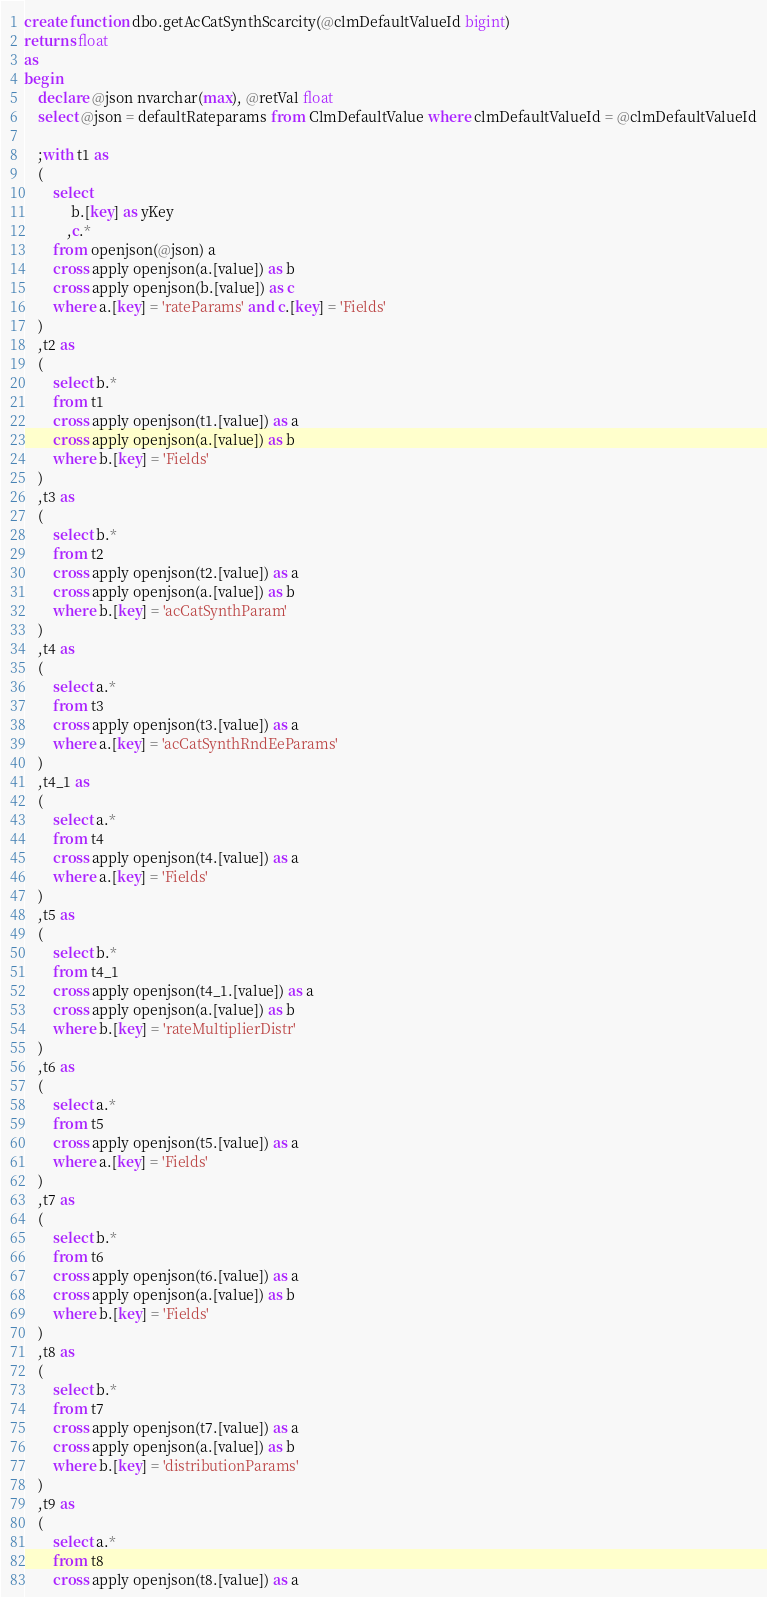<code> <loc_0><loc_0><loc_500><loc_500><_SQL_>create function dbo.getAcCatSynthScarcity(@clmDefaultValueId bigint)
returns float
as
begin
	declare @json nvarchar(max), @retVal float
	select @json = defaultRateparams from ClmDefaultValue where clmDefaultValueId = @clmDefaultValueId

	;with t1 as
	(
		select 
			 b.[key] as yKey
			,c.*
		from openjson(@json) a
		cross apply openjson(a.[value]) as b
		cross apply openjson(b.[value]) as c
		where a.[key] = 'rateParams' and c.[key] = 'Fields'
	)
	,t2 as
	(
		select b.* 
		from t1
		cross apply openjson(t1.[value]) as a
		cross apply openjson(a.[value]) as b
		where b.[key] = 'Fields'
	)
	,t3 as
	(
		select b.* 
		from t2
		cross apply openjson(t2.[value]) as a
		cross apply openjson(a.[value]) as b
		where b.[key] = 'acCatSynthParam'
	)
	,t4 as
	(
		select a.* 
		from t3
		cross apply openjson(t3.[value]) as a
		where a.[key] = 'acCatSynthRndEeParams'
	)
	,t4_1 as
	(
		select a.* 
		from t4
		cross apply openjson(t4.[value]) as a
		where a.[key] = 'Fields'
	)
	,t5 as
	(
		select b.*
		from t4_1
		cross apply openjson(t4_1.[value]) as a
		cross apply openjson(a.[value]) as b
		where b.[key] = 'rateMultiplierDistr'
	)
	,t6 as
	(
		select a.* 
		from t5
		cross apply openjson(t5.[value]) as a
		where a.[key] = 'Fields'
	)
	,t7 as
	(
		select b.*
		from t6
		cross apply openjson(t6.[value]) as a
		cross apply openjson(a.[value]) as b
		where b.[key] = 'Fields'
	)
	,t8 as
	(
		select b.* 
		from t7
		cross apply openjson(t7.[value]) as a
		cross apply openjson(a.[value]) as b
		where b.[key] = 'distributionParams'
	)
	,t9 as
	(
		select a.* 
		from t8
		cross apply openjson(t8.[value]) as a</code> 